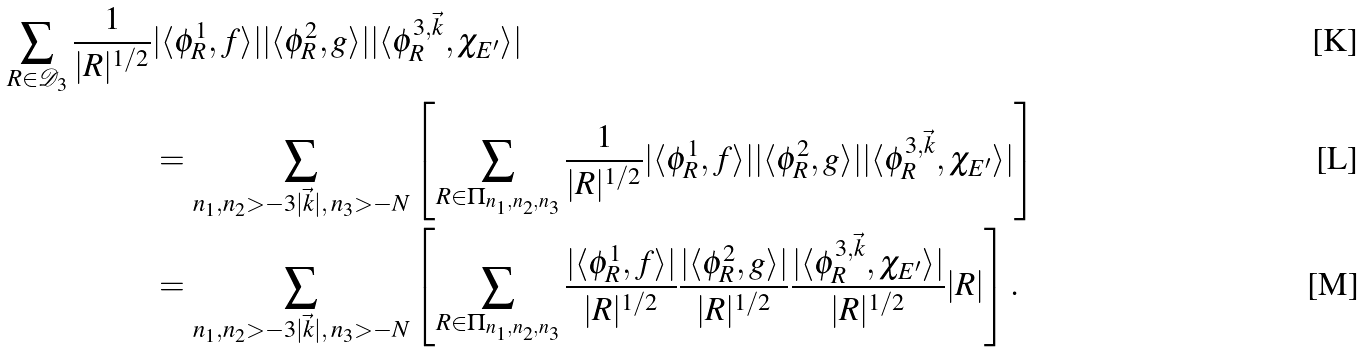Convert formula to latex. <formula><loc_0><loc_0><loc_500><loc_500>\sum _ { R \in \mathcal { D } _ { 3 } } \frac { 1 } { | R | ^ { 1 / 2 } } & | \langle \phi _ { R } ^ { 1 } , f \rangle | | \langle \phi _ { R } ^ { 2 } , g \rangle | | \langle \phi _ { R } ^ { 3 , \vec { k } } , \chi _ { E ^ { \prime } } \rangle | \\ & = \sum _ { n _ { 1 } , n _ { 2 } > - 3 | \vec { k } | , \, n _ { 3 } > - N } \left [ \sum _ { R \in \Pi _ { n _ { 1 } , n _ { 2 } , n _ { 3 } } } \frac { 1 } { | R | ^ { 1 / 2 } } | \langle \phi _ { R } ^ { 1 } , f \rangle | | \langle \phi _ { R } ^ { 2 } , g \rangle | | \langle \phi _ { R } ^ { 3 , \vec { k } } , \chi _ { E ^ { \prime } } \rangle | \right ] \\ & = \sum _ { n _ { 1 } , n _ { 2 } > - 3 | \vec { k } | , \, n _ { 3 } > - N } \left [ \sum _ { R \in \Pi _ { n _ { 1 } , n _ { 2 } , n _ { 3 } } } \frac { | \langle \phi _ { R } ^ { 1 } , f \rangle | } { | R | ^ { 1 / 2 } } \frac { | \langle \phi _ { R } ^ { 2 } , g \rangle | } { | R | ^ { 1 / 2 } } \frac { | \langle \phi _ { R } ^ { 3 , \vec { k } } , \chi _ { E ^ { \prime } } \rangle | } { | R | ^ { 1 / 2 } } | R | \right ] .</formula> 